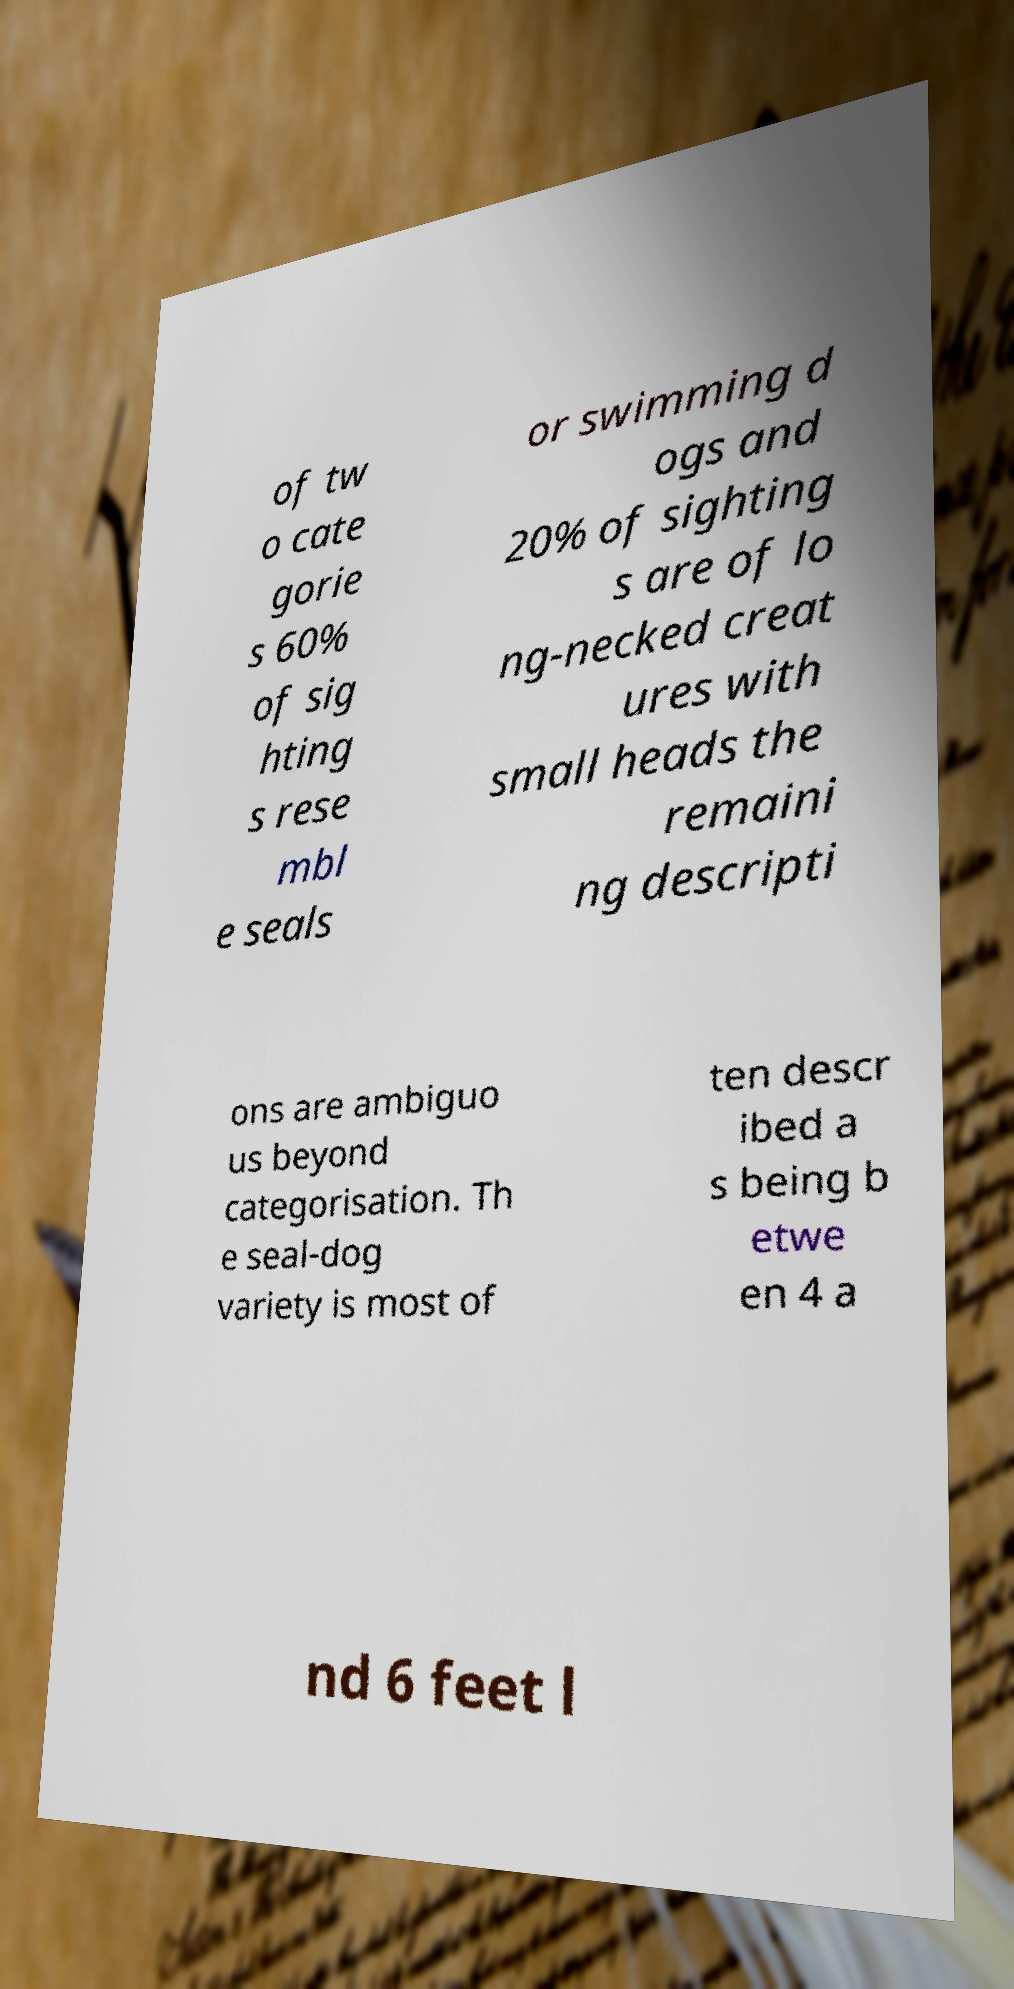Could you assist in decoding the text presented in this image and type it out clearly? of tw o cate gorie s 60% of sig hting s rese mbl e seals or swimming d ogs and 20% of sighting s are of lo ng-necked creat ures with small heads the remaini ng descripti ons are ambiguo us beyond categorisation. Th e seal-dog variety is most of ten descr ibed a s being b etwe en 4 a nd 6 feet l 